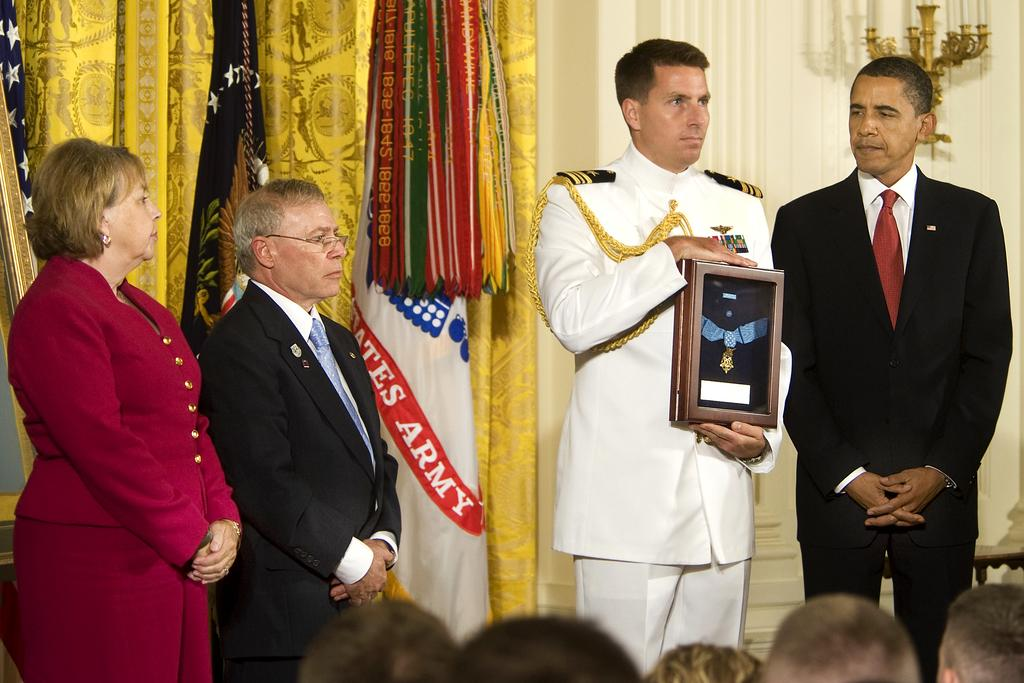<image>
Describe the image concisely. A banner with the word army on it can be seen next to a serviceman receiving an award. 